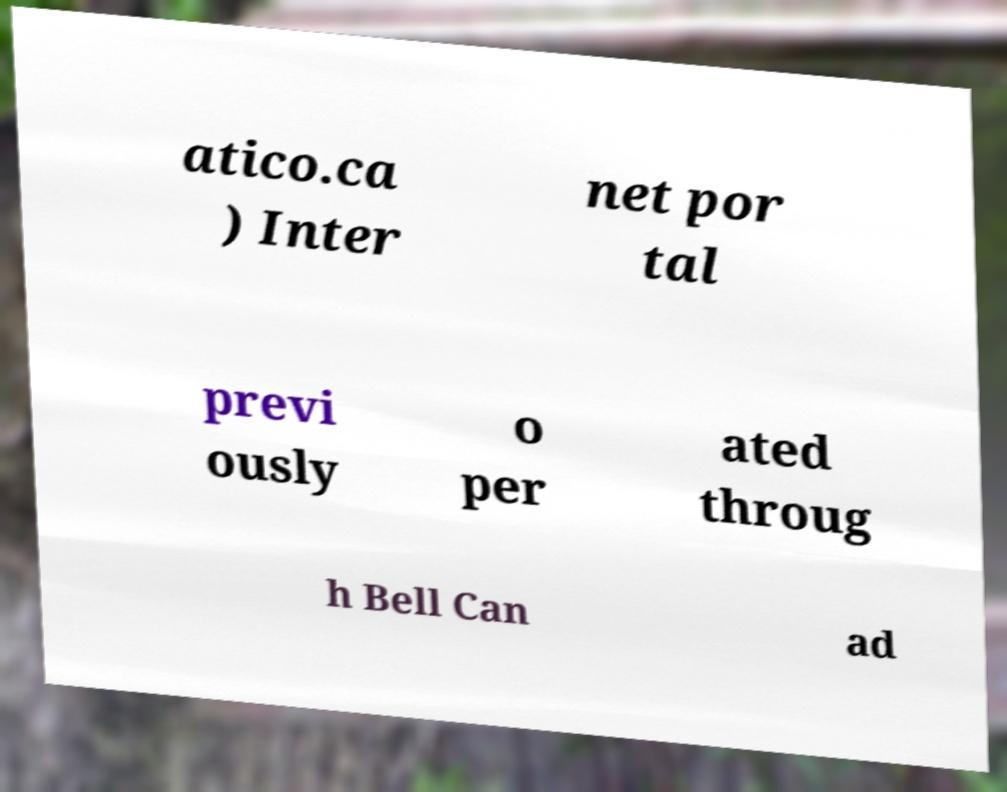For documentation purposes, I need the text within this image transcribed. Could you provide that? atico.ca ) Inter net por tal previ ously o per ated throug h Bell Can ad 